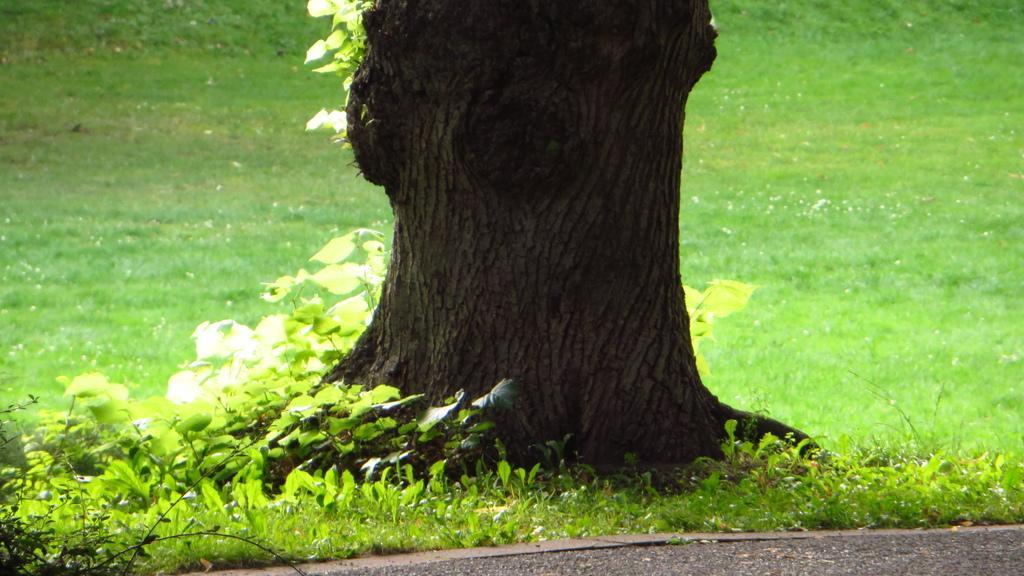Could you give a brief overview of what you see in this image? Land is covered with grass. Here we can see plants and tree trunk. 